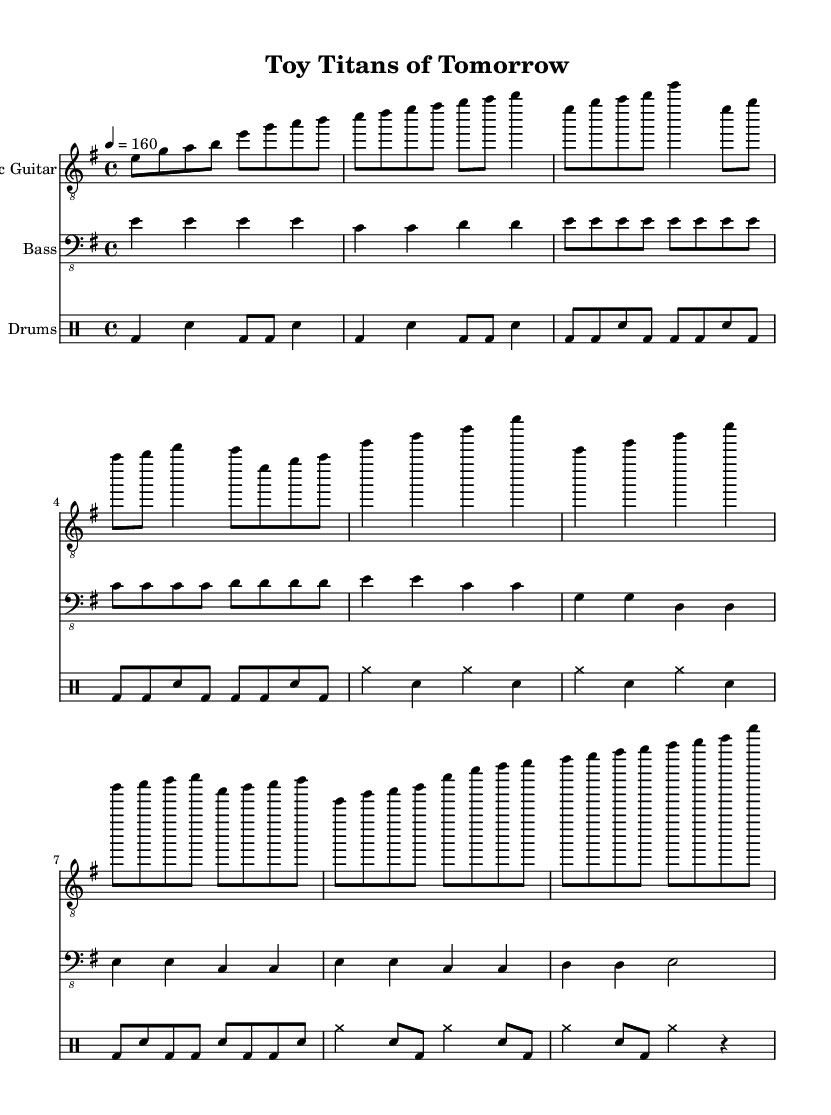What is the key signature of this music? The key signature is indicated at the beginning of the sheet music and shows that there is one sharp (F#), which corresponds to E minor.
Answer: E minor What is the time signature of this music? The time signature is specified in the music and is written as a fraction, showing that there are four beats per measure, which is indicated as 4/4.
Answer: 4/4 What is the tempo marking for this piece? The tempo marking is shown above the music, indicating a tempo of 160 beats per minute, described as 4 = 160.
Answer: 160 How many measures are in the chorus section? By counting the measures visibly noted in the sheet music, we find that the chorus has a total of four measures.
Answer: Four What instruments are featured in this score? The instruments are mentioned at the start of each staff: Electric Guitar, Bass, and Drums, which showcases a typical setup for a metal band.
Answer: Electric Guitar, Bass, Drums How does the bridge differ from the introductory section? The bridge is characterized by adding complexity and variation as it plays different notes and rhythms compared to the simpler introductory section which is more repetitive.
Answer: More complex What type of rhythm is primarily used in the drum part? The primary rhythm shown in the drum part consists of bass drum hits and snare backbeats, typical for the metal genre, focusing on driving tempos and aggressive patterns.
Answer: Bass and snare 